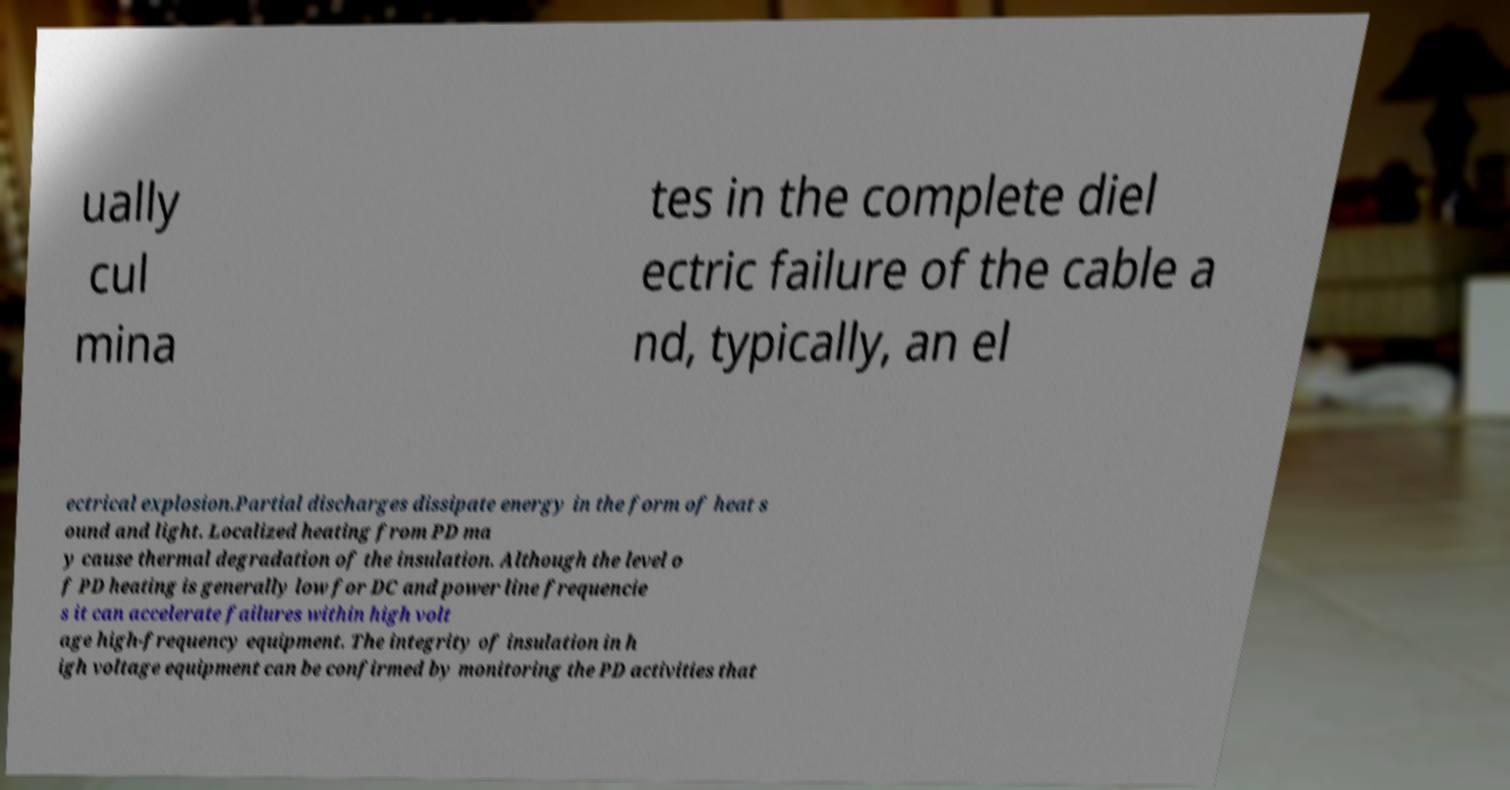Could you assist in decoding the text presented in this image and type it out clearly? ually cul mina tes in the complete diel ectric failure of the cable a nd, typically, an el ectrical explosion.Partial discharges dissipate energy in the form of heat s ound and light. Localized heating from PD ma y cause thermal degradation of the insulation. Although the level o f PD heating is generally low for DC and power line frequencie s it can accelerate failures within high volt age high-frequency equipment. The integrity of insulation in h igh voltage equipment can be confirmed by monitoring the PD activities that 